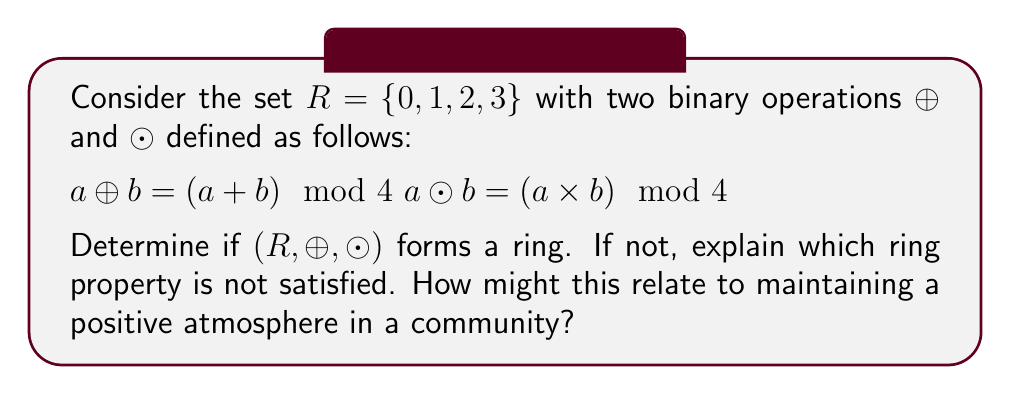Give your solution to this math problem. To determine if $(R, \oplus, \odot)$ forms a ring, we need to check if it satisfies all the ring axioms:

1. $(R, \oplus)$ is an abelian group:
   a) Closure: $\forall a, b \in R, a \oplus b \in R$ (satisfied by definition)
   b) Associativity: $(a \oplus b) \oplus c = a \oplus (b \oplus c)$ (satisfied due to modular arithmetic)
   c) Commutativity: $a \oplus b = b \oplus a$ (satisfied due to commutativity of addition)
   d) Identity: $0 \oplus a = a \oplus 0 = a$ for all $a \in R$ (0 is the identity)
   e) Inverse: For each $a \in R$, there exists $-a \in R$ such that $a \oplus (-a) = 0$
      $-0 = 0, -1 = 3, -2 = 2, -3 = 1$ (satisfied)

2. $(R, \odot)$ is associative:
   $(a \odot b) \odot c = a \odot (b \odot c)$ (satisfied due to modular arithmetic)

3. Distributivity:
   $a \odot (b \oplus c) = (a \odot b) \oplus (a \odot c)$
   $(b \oplus c) \odot a = (b \odot a) \oplus (c \odot a)$

Let's check distributivity:
$2 \odot (1 \oplus 3) = 2 \odot 0 = 0$
$(2 \odot 1) \oplus (2 \odot 3) = 2 \oplus 2 = 0$

Distributivity holds for this case and all other combinations (you can verify).

Therefore, $(R, \oplus, \odot)$ forms a ring.

This relates to maintaining a positive atmosphere in a community because, like a ring structure, a supportive community requires well-defined "operations" (interactions) that satisfy certain properties. Just as the ring has closure, associativity, and distributivity, a positive community has consistent rules, fair treatment, and the ability to resolve conflicts constructively. The identity element in the ring can be likened to the neutral, respectful baseline of interaction in the community.
Answer: Yes, $(R, \oplus, \odot)$ forms a ring. All ring axioms are satisfied, including closure, associativity, commutativity, identity, inverse for $(R, \oplus)$, associativity for $(R, \odot)$, and distributivity of $\odot$ over $\oplus$. 